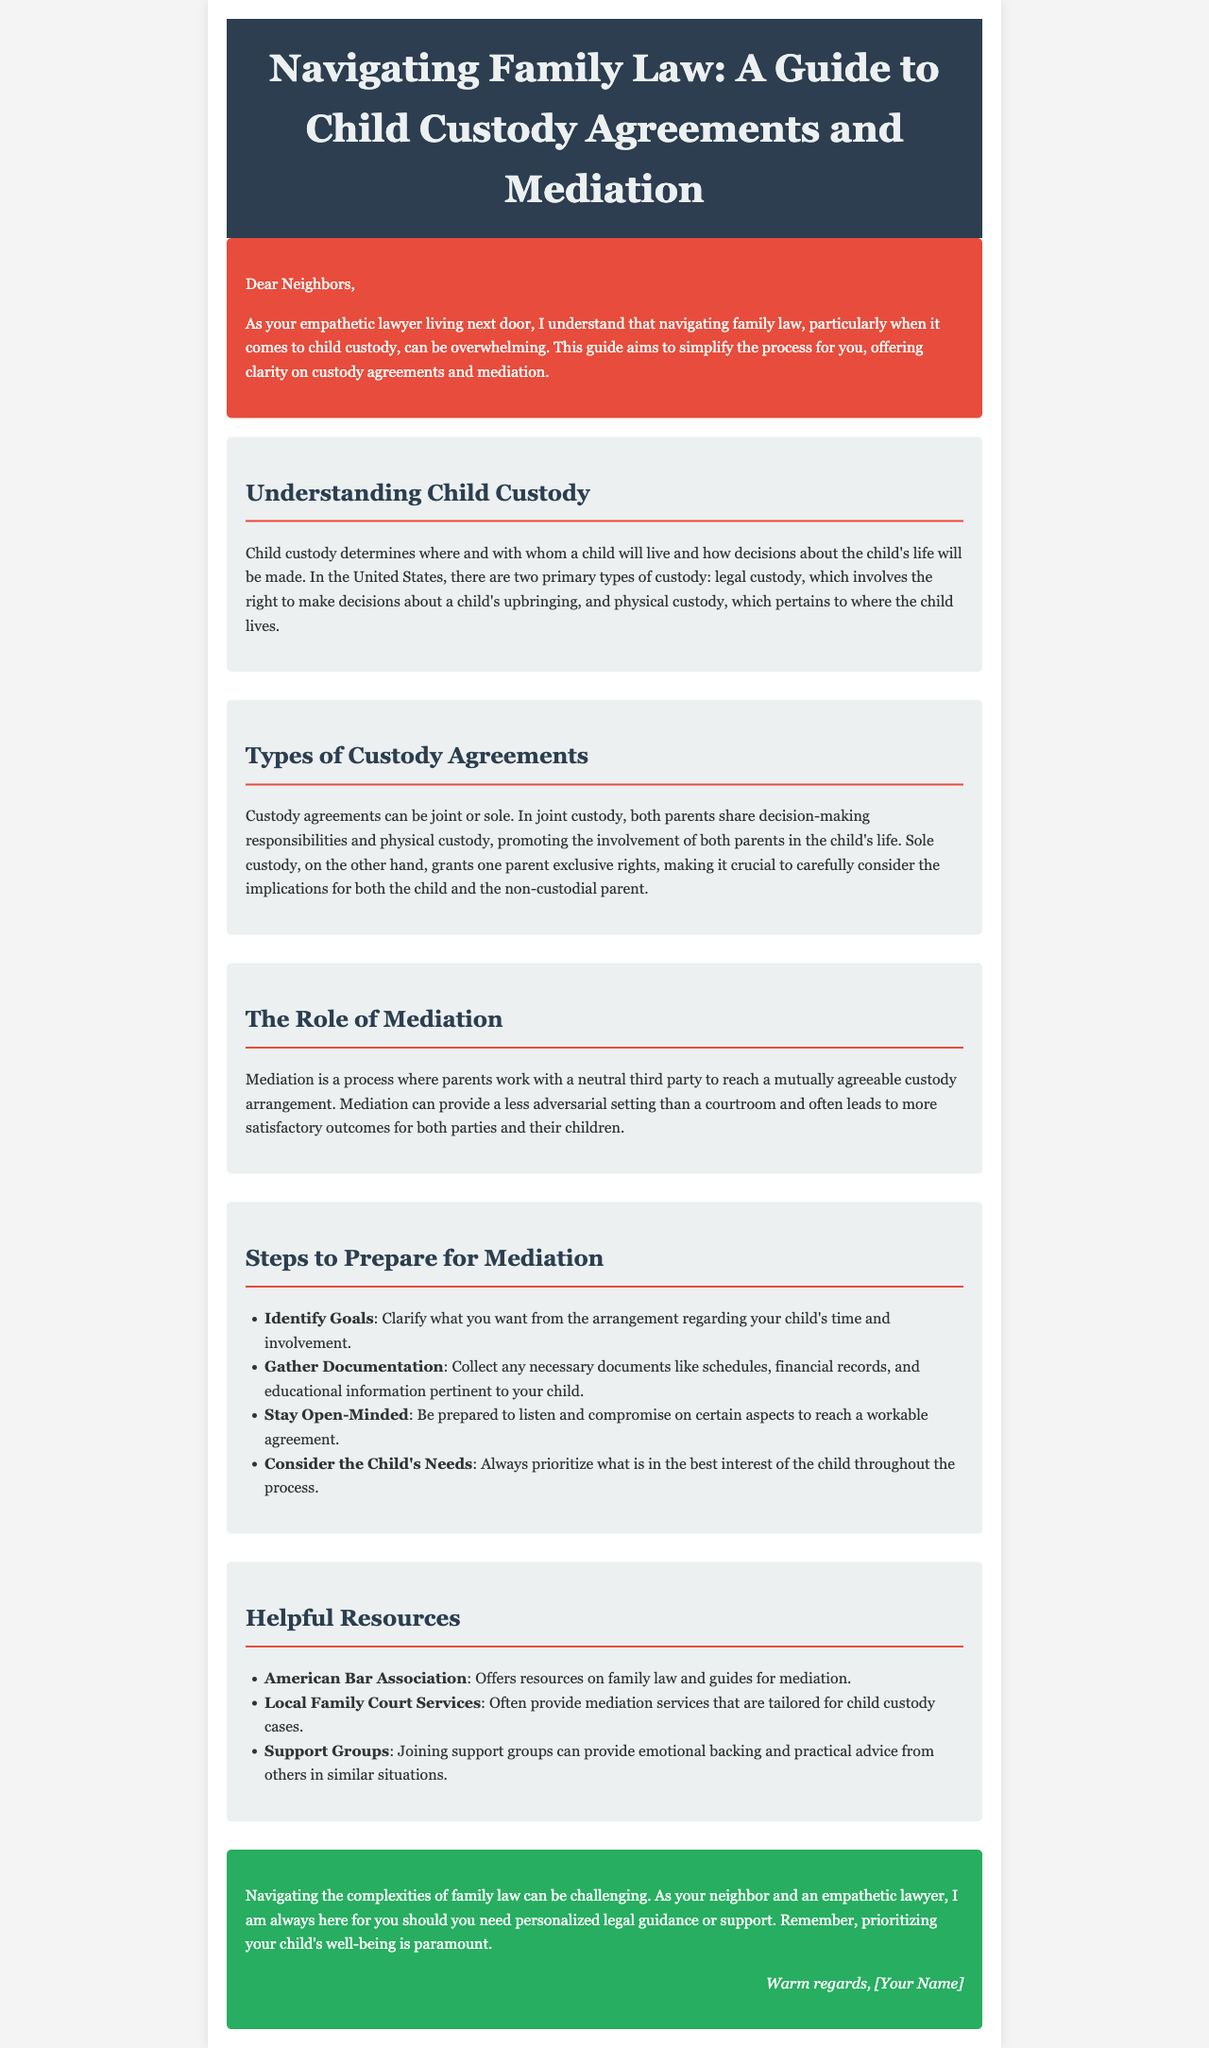What are the two primary types of custody? The document states that there are two primary types of custody: legal custody and physical custody.
Answer: legal custody, physical custody What does joint custody promote? The document explains that joint custody promotes the involvement of both parents in the child's life.
Answer: involvement of both parents What is mediation? Mediation is defined as a process where parents work with a neutral third party to reach a mutually agreeable custody arrangement.
Answer: a process with a neutral third party What should you prioritize during the mediation process? The document emphasizes that one should always prioritize what is in the best interest of the child.
Answer: best interest of the child Which organization offers resources on family law? The document lists the American Bar Association as an organization that offers resources on family law.
Answer: American Bar Association How many steps are there to prepare for mediation? The document outlines four steps to prepare for mediation.
Answer: four What type of custody grants one parent exclusive rights? The document describes sole custody as granting one parent exclusive rights.
Answer: sole custody What is listed as a helpful resource for mediation services? Local Family Court Services is mentioned as providing tailored mediation services for child custody cases.
Answer: Local Family Court Services 